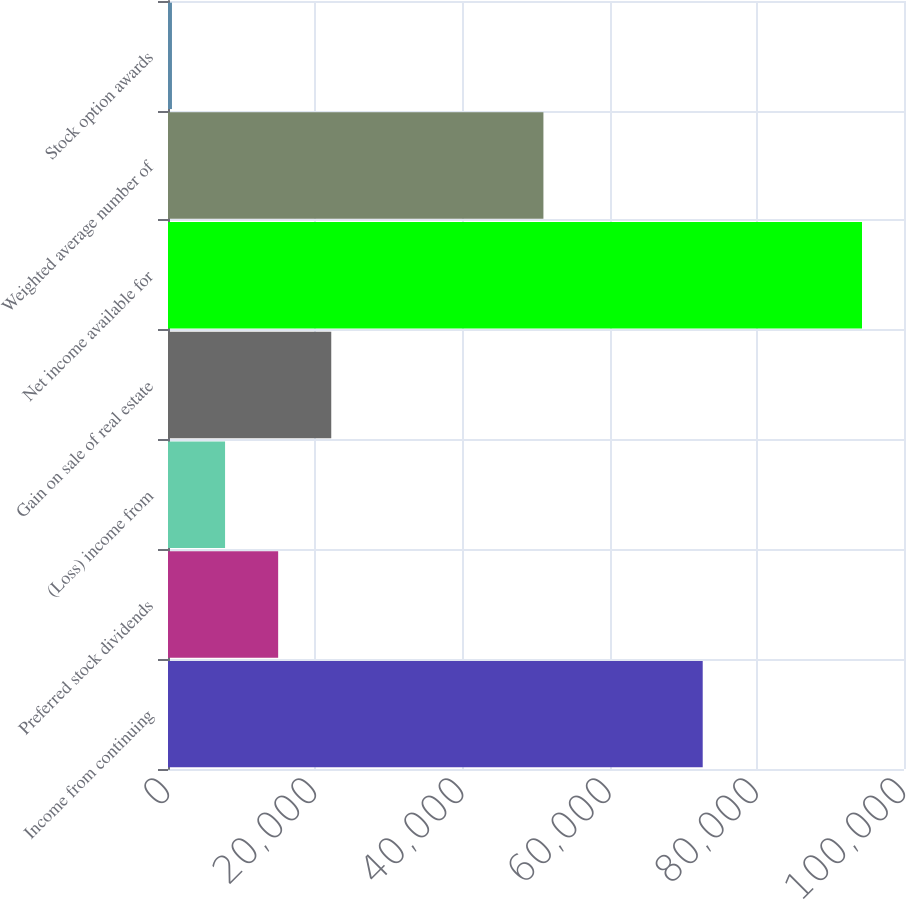Convert chart. <chart><loc_0><loc_0><loc_500><loc_500><bar_chart><fcel>Income from continuing<fcel>Preferred stock dividends<fcel>(Loss) income from<fcel>Gain on sale of real estate<fcel>Net income available for<fcel>Weighted average number of<fcel>Stock option awards<nl><fcel>72650.6<fcel>14967.4<fcel>7753.2<fcel>22181.6<fcel>94293.2<fcel>51008<fcel>539<nl></chart> 